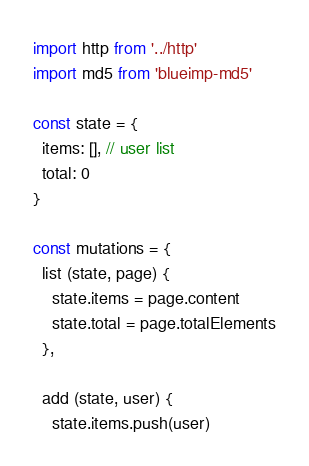<code> <loc_0><loc_0><loc_500><loc_500><_JavaScript_>import http from '../http'
import md5 from 'blueimp-md5'

const state = {
  items: [], // user list
  total: 0
}

const mutations = {
  list (state, page) {
    state.items = page.content
    state.total = page.totalElements
  },

  add (state, user) {
    state.items.push(user)</code> 